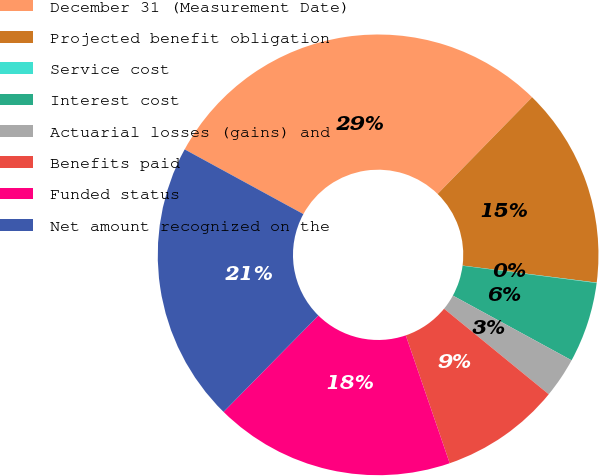Convert chart to OTSL. <chart><loc_0><loc_0><loc_500><loc_500><pie_chart><fcel>December 31 (Measurement Date)<fcel>Projected benefit obligation<fcel>Service cost<fcel>Interest cost<fcel>Actuarial losses (gains) and<fcel>Benefits paid<fcel>Funded status<fcel>Net amount recognized on the<nl><fcel>29.37%<fcel>14.7%<fcel>0.03%<fcel>5.9%<fcel>2.96%<fcel>8.83%<fcel>17.64%<fcel>20.57%<nl></chart> 